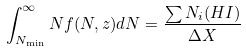<formula> <loc_0><loc_0><loc_500><loc_500>\int _ { N _ { \min } } ^ { \infty } N f ( N , z ) d N = \frac { \sum N _ { i } ( H I ) } { \Delta X }</formula> 